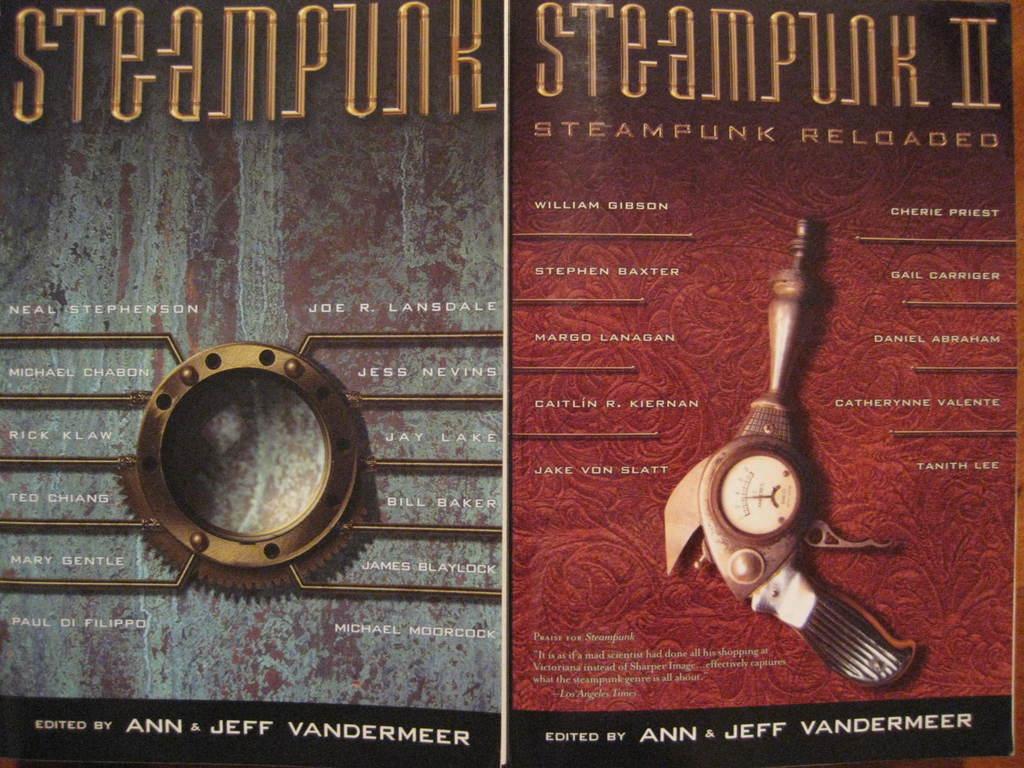Who are these edited by?
Ensure brevity in your answer.  Ann & jeff vandermeer. What is the title of the book on the left?
Ensure brevity in your answer.  Steampunk. 